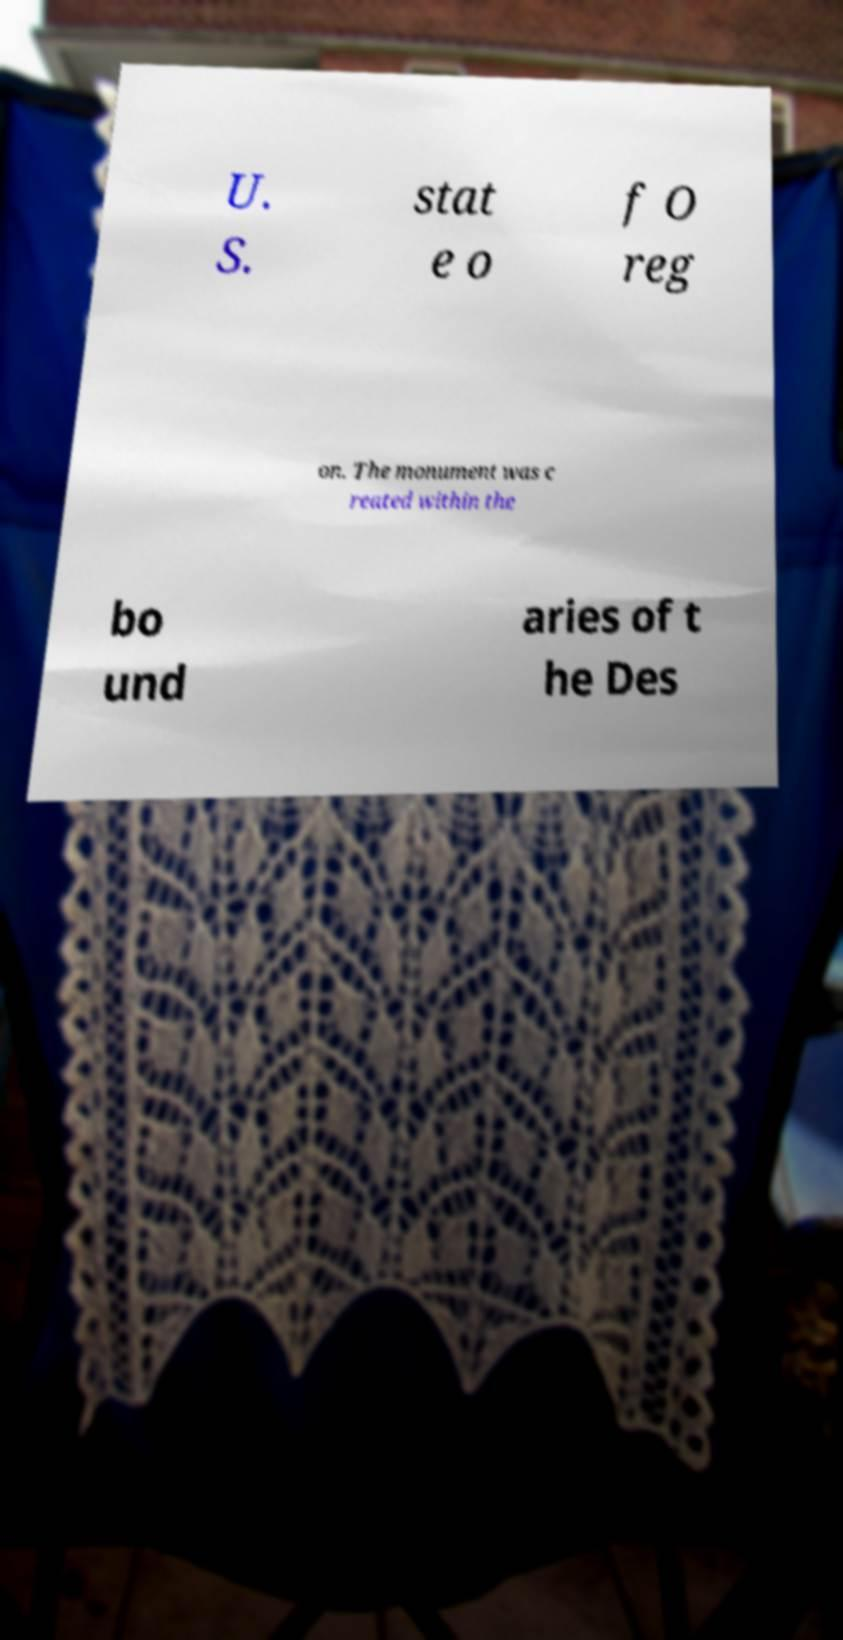Could you extract and type out the text from this image? U. S. stat e o f O reg on. The monument was c reated within the bo und aries of t he Des 